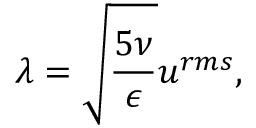<formula> <loc_0><loc_0><loc_500><loc_500>\lambda = \sqrt { \frac { 5 \nu } { \epsilon } } u ^ { r m s } ,</formula> 